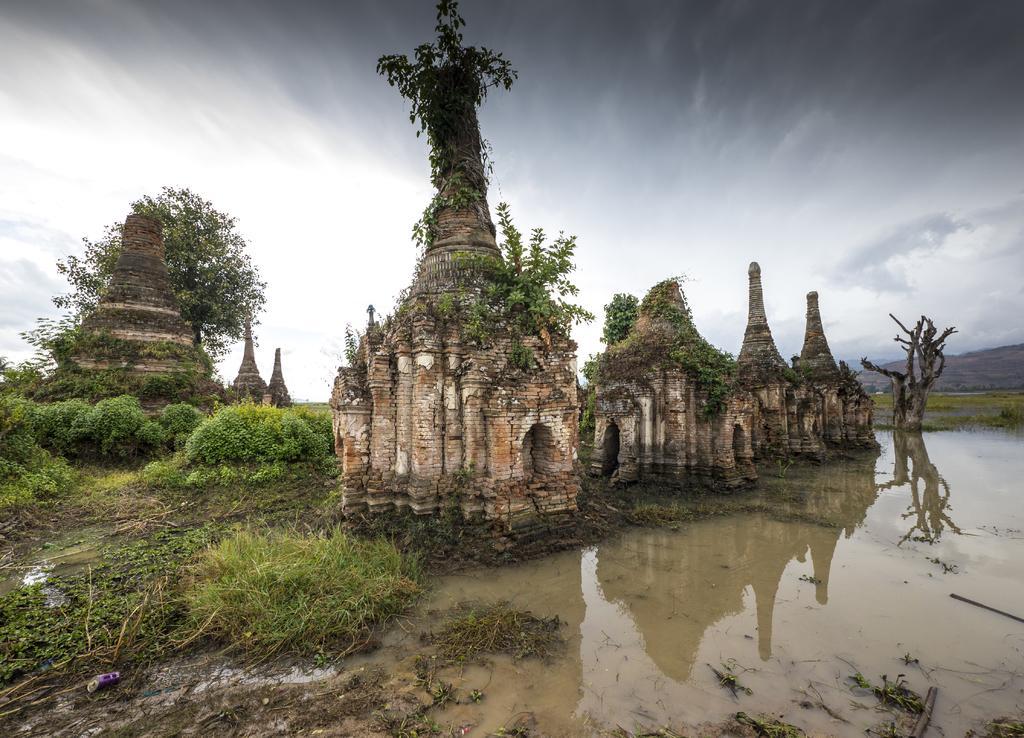In one or two sentences, can you explain what this image depicts? This is an outside view. Here I can see the ruins. On the right side, I can see the water. On the left side there are many plants and trees. At the top of the image I can see the sky. 